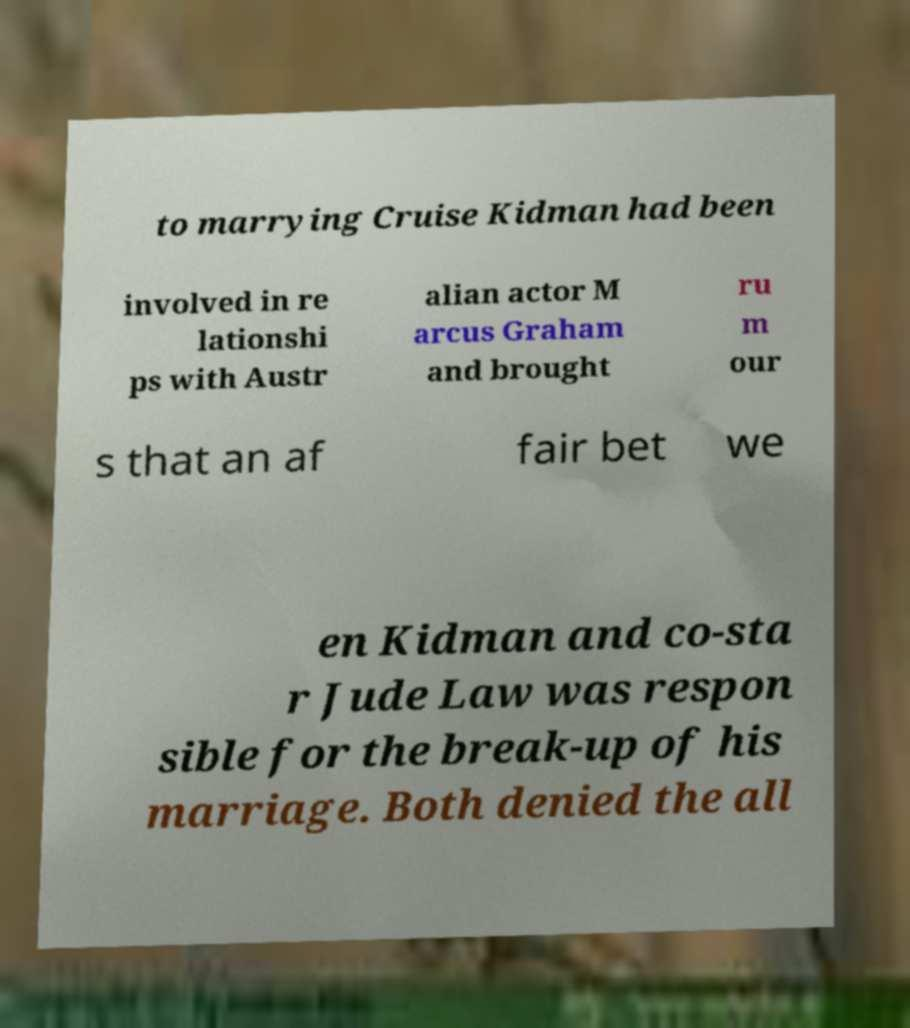Please read and relay the text visible in this image. What does it say? to marrying Cruise Kidman had been involved in re lationshi ps with Austr alian actor M arcus Graham and brought ru m our s that an af fair bet we en Kidman and co-sta r Jude Law was respon sible for the break-up of his marriage. Both denied the all 